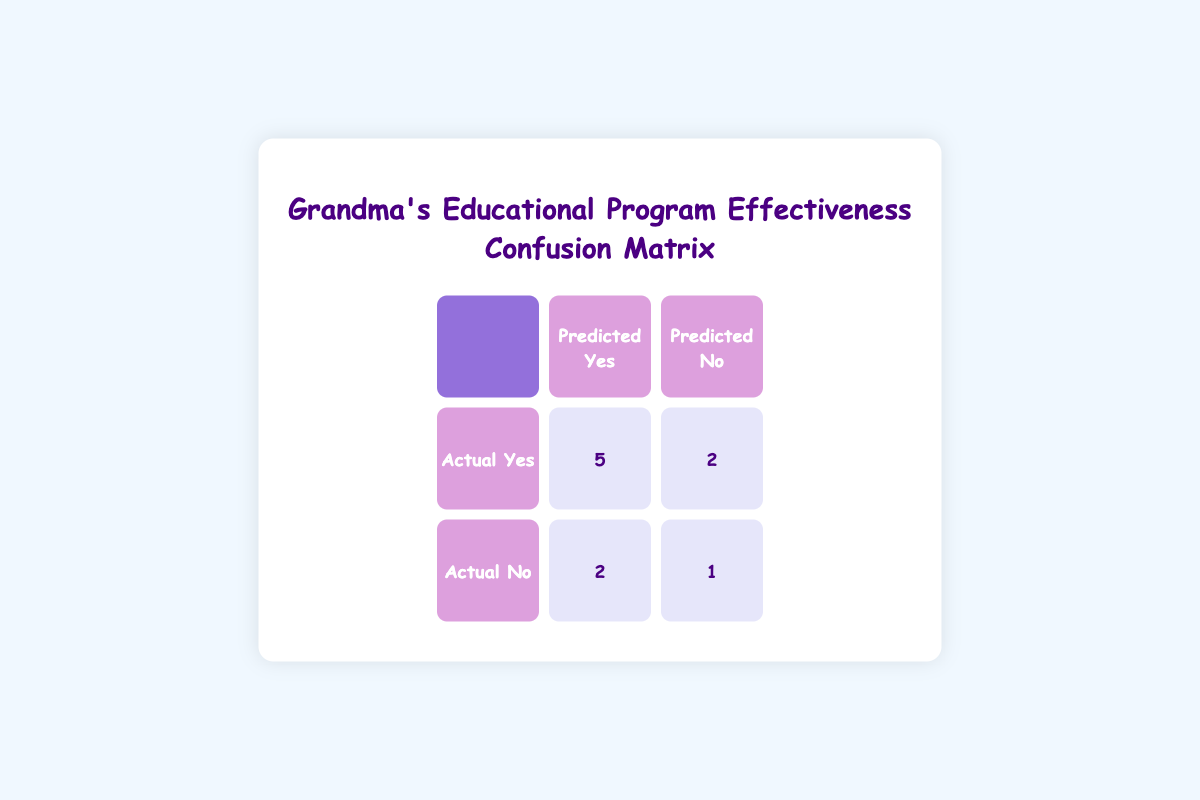What is the number of children who showed improvement after participating in the programs? From the confusion matrix, the number of children who actually showed improvement (Actual Yes) is the sum of the values in the "Predicted Yes" column: 5 (predicted Yes, actual Yes) + 2 (predicted No, actual Yes) = 7.
Answer: 7 What percentage of children who were predicted to improve actually showed improvement? To find this percentage, we take the number of children who were predicted to improve and actually did improve (5) and divide it by the total number of children predicted to improve (5 + 2 = 7). Thus, the percentage is (5/7) * 100 = 71.43%, rounding to two decimal points.
Answer: 71.43% How many children did not show improvement from the programs? The total number of children who did not show improvement (Actual No) is the sum of those who were predicted to improve but did not (2) and those who were predicted not to improve and also did not (1): 2 + 1 = 3.
Answer: 3 Is it true that more children showed improvement than did not? Yes, there are 7 children who showed improvement (Actual Yes), compared to 3 children who did not show improvement (Actual No). Since 7 is greater than 3, the statement is true.
Answer: Yes What is the ratio of children who improved compared to those who did not improve? The number of children who improved is 7, and the number who did not improve is 3. Therefore, the ratio is 7:3, which can also be expressed in simplest forms as approximately 2.33:1.
Answer: 7:3 